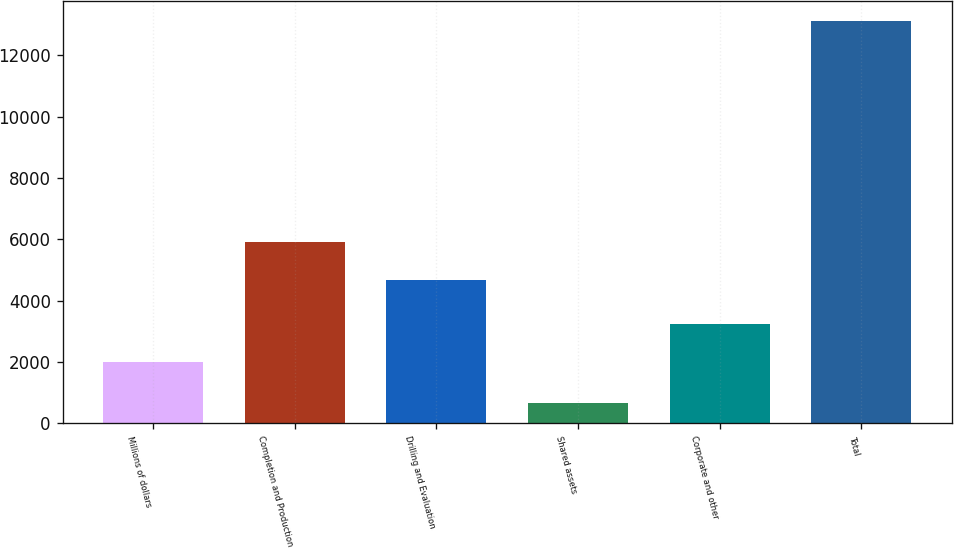Convert chart. <chart><loc_0><loc_0><loc_500><loc_500><bar_chart><fcel>Millions of dollars<fcel>Completion and Production<fcel>Drilling and Evaluation<fcel>Shared assets<fcel>Corporate and other<fcel>Total<nl><fcel>2007<fcel>5931.3<fcel>4685<fcel>672<fcel>3253.3<fcel>13135<nl></chart> 